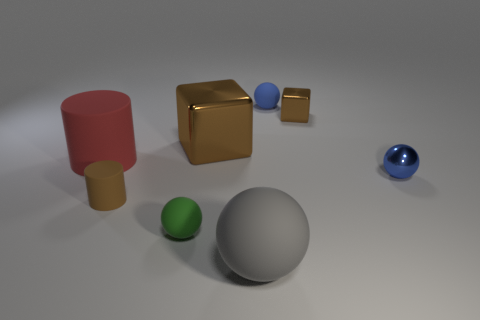Is the material of the small brown block the same as the large sphere?
Keep it short and to the point. No. Are there an equal number of spheres that are to the left of the large gray ball and big red matte objects behind the small blue matte sphere?
Your answer should be compact. No. There is a blue matte thing; how many tiny brown matte cylinders are to the right of it?
Keep it short and to the point. 0. What number of things are either shiny cubes or large gray matte spheres?
Ensure brevity in your answer.  3. How many matte objects are the same size as the green matte sphere?
Your answer should be very brief. 2. What is the shape of the small rubber thing to the right of the small green sphere in front of the tiny blue matte object?
Provide a succinct answer. Sphere. Is the number of tiny red metal cylinders less than the number of balls?
Keep it short and to the point. Yes. What color is the shiny block to the left of the large gray matte ball?
Your answer should be very brief. Brown. There is a brown thing that is left of the small cube and on the right side of the green matte sphere; what material is it made of?
Keep it short and to the point. Metal. What is the shape of the other brown object that is the same material as the big brown thing?
Give a very brief answer. Cube. 